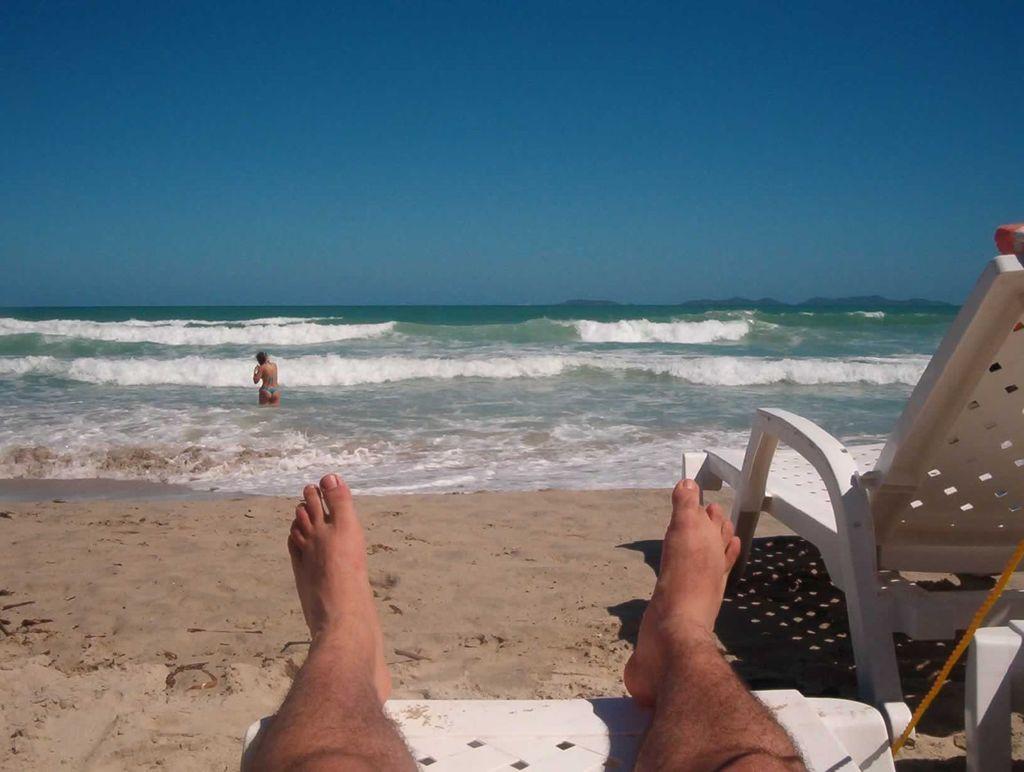Could you give a brief overview of what you see in this image? In this image I can see a person laying on the chair and the chair is in white color, background I can see the other person in the water and the sky is in blue color. 